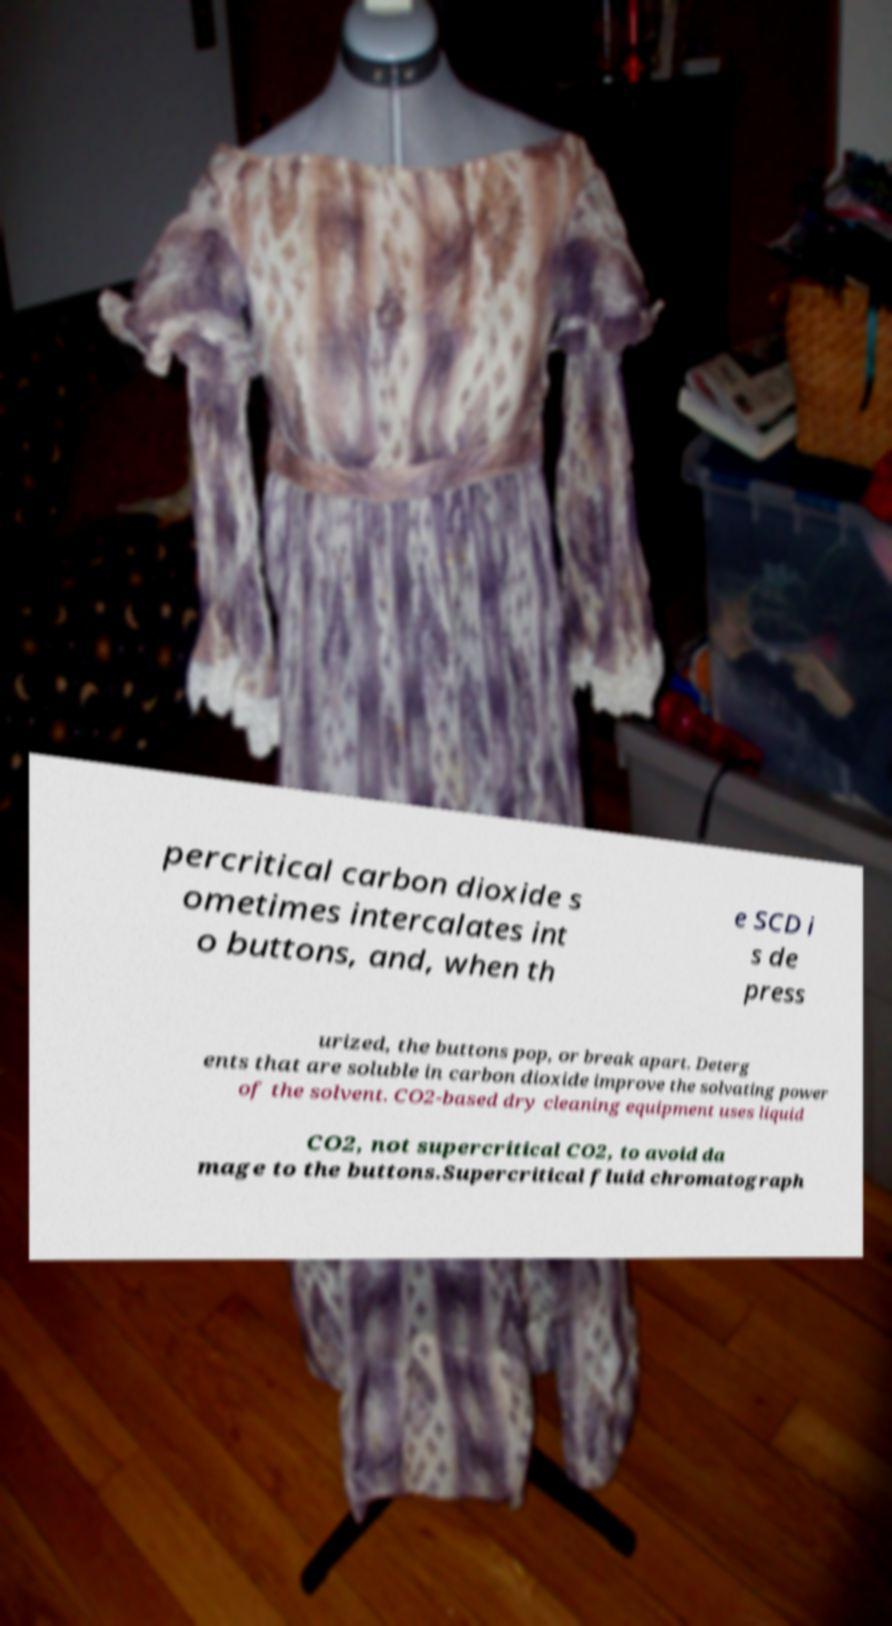For documentation purposes, I need the text within this image transcribed. Could you provide that? percritical carbon dioxide s ometimes intercalates int o buttons, and, when th e SCD i s de press urized, the buttons pop, or break apart. Deterg ents that are soluble in carbon dioxide improve the solvating power of the solvent. CO2-based dry cleaning equipment uses liquid CO2, not supercritical CO2, to avoid da mage to the buttons.Supercritical fluid chromatograph 